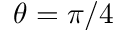<formula> <loc_0><loc_0><loc_500><loc_500>\theta = \pi / 4</formula> 